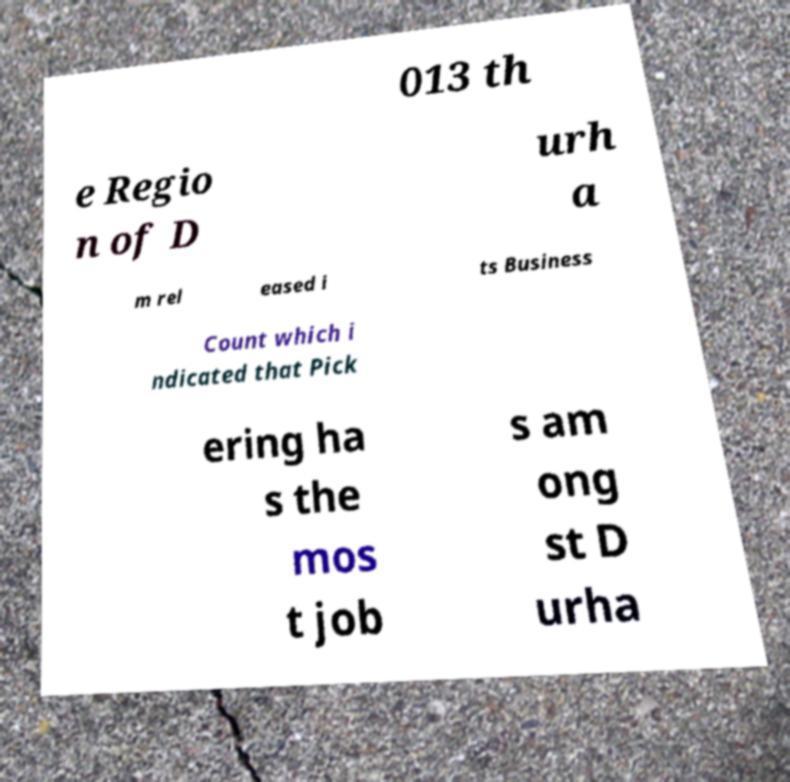There's text embedded in this image that I need extracted. Can you transcribe it verbatim? 013 th e Regio n of D urh a m rel eased i ts Business Count which i ndicated that Pick ering ha s the mos t job s am ong st D urha 